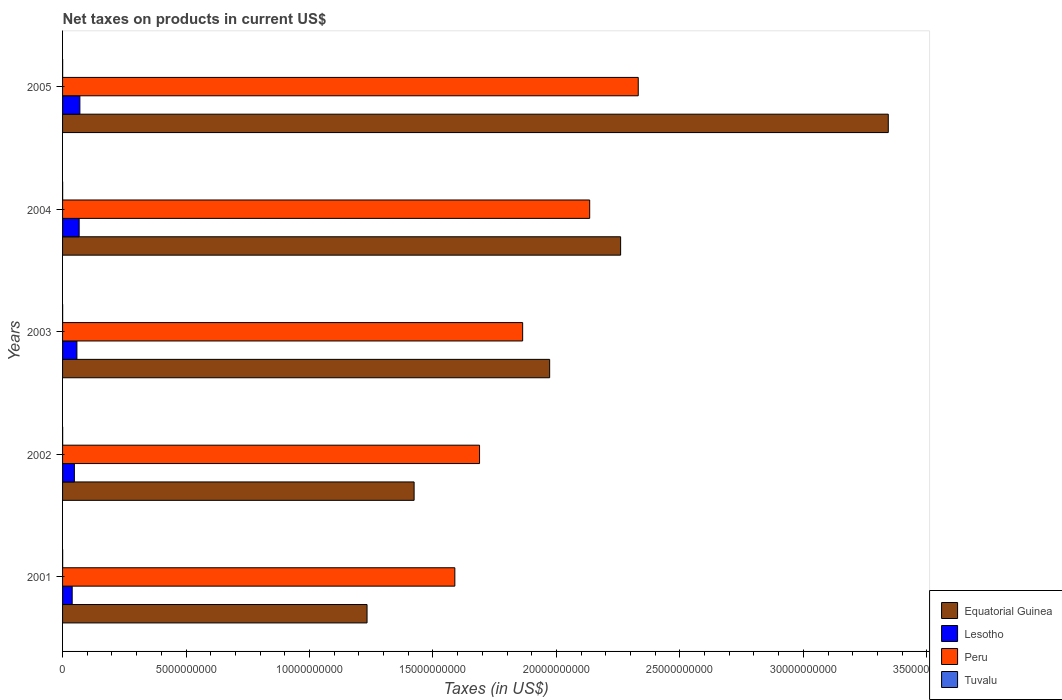How many different coloured bars are there?
Provide a succinct answer. 4. How many bars are there on the 3rd tick from the bottom?
Keep it short and to the point. 4. What is the net taxes on products in Peru in 2001?
Your answer should be very brief. 1.59e+1. Across all years, what is the maximum net taxes on products in Tuvalu?
Provide a short and direct response. 3.51e+06. Across all years, what is the minimum net taxes on products in Equatorial Guinea?
Make the answer very short. 1.23e+1. In which year was the net taxes on products in Peru minimum?
Your answer should be compact. 2001. What is the total net taxes on products in Tuvalu in the graph?
Your response must be concise. 1.58e+07. What is the difference between the net taxes on products in Lesotho in 2001 and that in 2004?
Your answer should be very brief. -2.82e+08. What is the difference between the net taxes on products in Tuvalu in 2004 and the net taxes on products in Lesotho in 2001?
Your response must be concise. -3.87e+08. What is the average net taxes on products in Tuvalu per year?
Provide a succinct answer. 3.16e+06. In the year 2005, what is the difference between the net taxes on products in Equatorial Guinea and net taxes on products in Tuvalu?
Your response must be concise. 3.34e+1. In how many years, is the net taxes on products in Tuvalu greater than 28000000000 US$?
Keep it short and to the point. 0. What is the ratio of the net taxes on products in Peru in 2002 to that in 2004?
Keep it short and to the point. 0.79. Is the difference between the net taxes on products in Equatorial Guinea in 2001 and 2003 greater than the difference between the net taxes on products in Tuvalu in 2001 and 2003?
Your answer should be compact. No. What is the difference between the highest and the second highest net taxes on products in Lesotho?
Your answer should be compact. 2.91e+07. What is the difference between the highest and the lowest net taxes on products in Peru?
Provide a succinct answer. 7.43e+09. In how many years, is the net taxes on products in Equatorial Guinea greater than the average net taxes on products in Equatorial Guinea taken over all years?
Make the answer very short. 2. Is the sum of the net taxes on products in Lesotho in 2003 and 2004 greater than the maximum net taxes on products in Peru across all years?
Offer a terse response. No. What does the 3rd bar from the top in 2005 represents?
Offer a very short reply. Lesotho. What does the 2nd bar from the bottom in 2001 represents?
Give a very brief answer. Lesotho. How many bars are there?
Provide a short and direct response. 20. Are all the bars in the graph horizontal?
Provide a succinct answer. Yes. Are the values on the major ticks of X-axis written in scientific E-notation?
Provide a succinct answer. No. Does the graph contain grids?
Provide a succinct answer. No. How are the legend labels stacked?
Provide a succinct answer. Vertical. What is the title of the graph?
Provide a succinct answer. Net taxes on products in current US$. Does "Botswana" appear as one of the legend labels in the graph?
Offer a very short reply. No. What is the label or title of the X-axis?
Your response must be concise. Taxes (in US$). What is the label or title of the Y-axis?
Offer a very short reply. Years. What is the Taxes (in US$) of Equatorial Guinea in 2001?
Offer a very short reply. 1.23e+1. What is the Taxes (in US$) of Lesotho in 2001?
Make the answer very short. 3.90e+08. What is the Taxes (in US$) in Peru in 2001?
Make the answer very short. 1.59e+1. What is the Taxes (in US$) of Tuvalu in 2001?
Your answer should be very brief. 3.51e+06. What is the Taxes (in US$) of Equatorial Guinea in 2002?
Your answer should be very brief. 1.42e+1. What is the Taxes (in US$) of Lesotho in 2002?
Provide a short and direct response. 4.78e+08. What is the Taxes (in US$) in Peru in 2002?
Your answer should be very brief. 1.69e+1. What is the Taxes (in US$) of Tuvalu in 2002?
Provide a succinct answer. 3.43e+06. What is the Taxes (in US$) in Equatorial Guinea in 2003?
Make the answer very short. 1.97e+1. What is the Taxes (in US$) in Lesotho in 2003?
Provide a short and direct response. 5.81e+08. What is the Taxes (in US$) in Peru in 2003?
Ensure brevity in your answer.  1.86e+1. What is the Taxes (in US$) in Tuvalu in 2003?
Give a very brief answer. 3.22e+06. What is the Taxes (in US$) in Equatorial Guinea in 2004?
Ensure brevity in your answer.  2.26e+1. What is the Taxes (in US$) in Lesotho in 2004?
Your answer should be compact. 6.72e+08. What is the Taxes (in US$) in Peru in 2004?
Your answer should be compact. 2.13e+1. What is the Taxes (in US$) in Tuvalu in 2004?
Offer a terse response. 2.87e+06. What is the Taxes (in US$) of Equatorial Guinea in 2005?
Keep it short and to the point. 3.34e+1. What is the Taxes (in US$) of Lesotho in 2005?
Offer a very short reply. 7.01e+08. What is the Taxes (in US$) of Peru in 2005?
Give a very brief answer. 2.33e+1. What is the Taxes (in US$) of Tuvalu in 2005?
Offer a terse response. 2.79e+06. Across all years, what is the maximum Taxes (in US$) in Equatorial Guinea?
Provide a short and direct response. 3.34e+1. Across all years, what is the maximum Taxes (in US$) in Lesotho?
Make the answer very short. 7.01e+08. Across all years, what is the maximum Taxes (in US$) in Peru?
Provide a short and direct response. 2.33e+1. Across all years, what is the maximum Taxes (in US$) in Tuvalu?
Offer a terse response. 3.51e+06. Across all years, what is the minimum Taxes (in US$) of Equatorial Guinea?
Ensure brevity in your answer.  1.23e+1. Across all years, what is the minimum Taxes (in US$) of Lesotho?
Provide a short and direct response. 3.90e+08. Across all years, what is the minimum Taxes (in US$) of Peru?
Ensure brevity in your answer.  1.59e+1. Across all years, what is the minimum Taxes (in US$) of Tuvalu?
Offer a very short reply. 2.79e+06. What is the total Taxes (in US$) of Equatorial Guinea in the graph?
Offer a very short reply. 1.02e+11. What is the total Taxes (in US$) of Lesotho in the graph?
Provide a short and direct response. 2.82e+09. What is the total Taxes (in US$) of Peru in the graph?
Provide a short and direct response. 9.61e+1. What is the total Taxes (in US$) in Tuvalu in the graph?
Give a very brief answer. 1.58e+07. What is the difference between the Taxes (in US$) of Equatorial Guinea in 2001 and that in 2002?
Offer a very short reply. -1.91e+09. What is the difference between the Taxes (in US$) of Lesotho in 2001 and that in 2002?
Give a very brief answer. -8.83e+07. What is the difference between the Taxes (in US$) of Peru in 2001 and that in 2002?
Your answer should be very brief. -1.00e+09. What is the difference between the Taxes (in US$) in Tuvalu in 2001 and that in 2002?
Your response must be concise. 8.68e+04. What is the difference between the Taxes (in US$) in Equatorial Guinea in 2001 and that in 2003?
Your answer should be very brief. -7.40e+09. What is the difference between the Taxes (in US$) of Lesotho in 2001 and that in 2003?
Your answer should be very brief. -1.91e+08. What is the difference between the Taxes (in US$) of Peru in 2001 and that in 2003?
Keep it short and to the point. -2.75e+09. What is the difference between the Taxes (in US$) of Tuvalu in 2001 and that in 2003?
Your answer should be very brief. 2.88e+05. What is the difference between the Taxes (in US$) of Equatorial Guinea in 2001 and that in 2004?
Your answer should be compact. -1.03e+1. What is the difference between the Taxes (in US$) in Lesotho in 2001 and that in 2004?
Provide a succinct answer. -2.82e+08. What is the difference between the Taxes (in US$) of Peru in 2001 and that in 2004?
Offer a terse response. -5.46e+09. What is the difference between the Taxes (in US$) in Tuvalu in 2001 and that in 2004?
Ensure brevity in your answer.  6.37e+05. What is the difference between the Taxes (in US$) of Equatorial Guinea in 2001 and that in 2005?
Your response must be concise. -2.11e+1. What is the difference between the Taxes (in US$) in Lesotho in 2001 and that in 2005?
Ensure brevity in your answer.  -3.11e+08. What is the difference between the Taxes (in US$) of Peru in 2001 and that in 2005?
Your response must be concise. -7.43e+09. What is the difference between the Taxes (in US$) of Tuvalu in 2001 and that in 2005?
Ensure brevity in your answer.  7.24e+05. What is the difference between the Taxes (in US$) of Equatorial Guinea in 2002 and that in 2003?
Make the answer very short. -5.49e+09. What is the difference between the Taxes (in US$) of Lesotho in 2002 and that in 2003?
Your answer should be compact. -1.03e+08. What is the difference between the Taxes (in US$) in Peru in 2002 and that in 2003?
Provide a succinct answer. -1.75e+09. What is the difference between the Taxes (in US$) in Tuvalu in 2002 and that in 2003?
Offer a very short reply. 2.01e+05. What is the difference between the Taxes (in US$) of Equatorial Guinea in 2002 and that in 2004?
Offer a very short reply. -8.36e+09. What is the difference between the Taxes (in US$) in Lesotho in 2002 and that in 2004?
Your answer should be very brief. -1.94e+08. What is the difference between the Taxes (in US$) in Peru in 2002 and that in 2004?
Your response must be concise. -4.46e+09. What is the difference between the Taxes (in US$) of Tuvalu in 2002 and that in 2004?
Provide a short and direct response. 5.50e+05. What is the difference between the Taxes (in US$) of Equatorial Guinea in 2002 and that in 2005?
Your answer should be very brief. -1.92e+1. What is the difference between the Taxes (in US$) of Lesotho in 2002 and that in 2005?
Ensure brevity in your answer.  -2.23e+08. What is the difference between the Taxes (in US$) in Peru in 2002 and that in 2005?
Give a very brief answer. -6.43e+09. What is the difference between the Taxes (in US$) in Tuvalu in 2002 and that in 2005?
Offer a terse response. 6.37e+05. What is the difference between the Taxes (in US$) of Equatorial Guinea in 2003 and that in 2004?
Your response must be concise. -2.87e+09. What is the difference between the Taxes (in US$) of Lesotho in 2003 and that in 2004?
Your answer should be compact. -9.11e+07. What is the difference between the Taxes (in US$) in Peru in 2003 and that in 2004?
Provide a short and direct response. -2.71e+09. What is the difference between the Taxes (in US$) of Tuvalu in 2003 and that in 2004?
Keep it short and to the point. 3.50e+05. What is the difference between the Taxes (in US$) of Equatorial Guinea in 2003 and that in 2005?
Your response must be concise. -1.37e+1. What is the difference between the Taxes (in US$) in Lesotho in 2003 and that in 2005?
Keep it short and to the point. -1.20e+08. What is the difference between the Taxes (in US$) of Peru in 2003 and that in 2005?
Your answer should be very brief. -4.68e+09. What is the difference between the Taxes (in US$) in Tuvalu in 2003 and that in 2005?
Give a very brief answer. 4.37e+05. What is the difference between the Taxes (in US$) of Equatorial Guinea in 2004 and that in 2005?
Offer a very short reply. -1.08e+1. What is the difference between the Taxes (in US$) in Lesotho in 2004 and that in 2005?
Offer a terse response. -2.91e+07. What is the difference between the Taxes (in US$) of Peru in 2004 and that in 2005?
Provide a succinct answer. -1.97e+09. What is the difference between the Taxes (in US$) in Tuvalu in 2004 and that in 2005?
Keep it short and to the point. 8.70e+04. What is the difference between the Taxes (in US$) in Equatorial Guinea in 2001 and the Taxes (in US$) in Lesotho in 2002?
Your answer should be very brief. 1.19e+1. What is the difference between the Taxes (in US$) of Equatorial Guinea in 2001 and the Taxes (in US$) of Peru in 2002?
Provide a succinct answer. -4.56e+09. What is the difference between the Taxes (in US$) in Equatorial Guinea in 2001 and the Taxes (in US$) in Tuvalu in 2002?
Your answer should be compact. 1.23e+1. What is the difference between the Taxes (in US$) of Lesotho in 2001 and the Taxes (in US$) of Peru in 2002?
Offer a very short reply. -1.65e+1. What is the difference between the Taxes (in US$) of Lesotho in 2001 and the Taxes (in US$) of Tuvalu in 2002?
Provide a succinct answer. 3.86e+08. What is the difference between the Taxes (in US$) of Peru in 2001 and the Taxes (in US$) of Tuvalu in 2002?
Offer a very short reply. 1.59e+1. What is the difference between the Taxes (in US$) of Equatorial Guinea in 2001 and the Taxes (in US$) of Lesotho in 2003?
Give a very brief answer. 1.18e+1. What is the difference between the Taxes (in US$) of Equatorial Guinea in 2001 and the Taxes (in US$) of Peru in 2003?
Your answer should be very brief. -6.30e+09. What is the difference between the Taxes (in US$) of Equatorial Guinea in 2001 and the Taxes (in US$) of Tuvalu in 2003?
Your answer should be very brief. 1.23e+1. What is the difference between the Taxes (in US$) in Lesotho in 2001 and the Taxes (in US$) in Peru in 2003?
Your response must be concise. -1.82e+1. What is the difference between the Taxes (in US$) in Lesotho in 2001 and the Taxes (in US$) in Tuvalu in 2003?
Your answer should be compact. 3.87e+08. What is the difference between the Taxes (in US$) in Peru in 2001 and the Taxes (in US$) in Tuvalu in 2003?
Make the answer very short. 1.59e+1. What is the difference between the Taxes (in US$) of Equatorial Guinea in 2001 and the Taxes (in US$) of Lesotho in 2004?
Your answer should be very brief. 1.17e+1. What is the difference between the Taxes (in US$) of Equatorial Guinea in 2001 and the Taxes (in US$) of Peru in 2004?
Offer a very short reply. -9.02e+09. What is the difference between the Taxes (in US$) of Equatorial Guinea in 2001 and the Taxes (in US$) of Tuvalu in 2004?
Your answer should be compact. 1.23e+1. What is the difference between the Taxes (in US$) in Lesotho in 2001 and the Taxes (in US$) in Peru in 2004?
Provide a succinct answer. -2.10e+1. What is the difference between the Taxes (in US$) in Lesotho in 2001 and the Taxes (in US$) in Tuvalu in 2004?
Your response must be concise. 3.87e+08. What is the difference between the Taxes (in US$) of Peru in 2001 and the Taxes (in US$) of Tuvalu in 2004?
Your answer should be compact. 1.59e+1. What is the difference between the Taxes (in US$) of Equatorial Guinea in 2001 and the Taxes (in US$) of Lesotho in 2005?
Offer a very short reply. 1.16e+1. What is the difference between the Taxes (in US$) of Equatorial Guinea in 2001 and the Taxes (in US$) of Peru in 2005?
Give a very brief answer. -1.10e+1. What is the difference between the Taxes (in US$) in Equatorial Guinea in 2001 and the Taxes (in US$) in Tuvalu in 2005?
Your answer should be very brief. 1.23e+1. What is the difference between the Taxes (in US$) in Lesotho in 2001 and the Taxes (in US$) in Peru in 2005?
Provide a short and direct response. -2.29e+1. What is the difference between the Taxes (in US$) in Lesotho in 2001 and the Taxes (in US$) in Tuvalu in 2005?
Provide a succinct answer. 3.87e+08. What is the difference between the Taxes (in US$) of Peru in 2001 and the Taxes (in US$) of Tuvalu in 2005?
Your answer should be very brief. 1.59e+1. What is the difference between the Taxes (in US$) in Equatorial Guinea in 2002 and the Taxes (in US$) in Lesotho in 2003?
Your answer should be compact. 1.37e+1. What is the difference between the Taxes (in US$) of Equatorial Guinea in 2002 and the Taxes (in US$) of Peru in 2003?
Give a very brief answer. -4.40e+09. What is the difference between the Taxes (in US$) in Equatorial Guinea in 2002 and the Taxes (in US$) in Tuvalu in 2003?
Your response must be concise. 1.42e+1. What is the difference between the Taxes (in US$) of Lesotho in 2002 and the Taxes (in US$) of Peru in 2003?
Give a very brief answer. -1.82e+1. What is the difference between the Taxes (in US$) of Lesotho in 2002 and the Taxes (in US$) of Tuvalu in 2003?
Make the answer very short. 4.75e+08. What is the difference between the Taxes (in US$) of Peru in 2002 and the Taxes (in US$) of Tuvalu in 2003?
Your answer should be compact. 1.69e+1. What is the difference between the Taxes (in US$) of Equatorial Guinea in 2002 and the Taxes (in US$) of Lesotho in 2004?
Offer a terse response. 1.36e+1. What is the difference between the Taxes (in US$) in Equatorial Guinea in 2002 and the Taxes (in US$) in Peru in 2004?
Keep it short and to the point. -7.11e+09. What is the difference between the Taxes (in US$) of Equatorial Guinea in 2002 and the Taxes (in US$) of Tuvalu in 2004?
Your answer should be very brief. 1.42e+1. What is the difference between the Taxes (in US$) of Lesotho in 2002 and the Taxes (in US$) of Peru in 2004?
Your answer should be very brief. -2.09e+1. What is the difference between the Taxes (in US$) in Lesotho in 2002 and the Taxes (in US$) in Tuvalu in 2004?
Provide a short and direct response. 4.75e+08. What is the difference between the Taxes (in US$) of Peru in 2002 and the Taxes (in US$) of Tuvalu in 2004?
Offer a terse response. 1.69e+1. What is the difference between the Taxes (in US$) of Equatorial Guinea in 2002 and the Taxes (in US$) of Lesotho in 2005?
Provide a succinct answer. 1.35e+1. What is the difference between the Taxes (in US$) in Equatorial Guinea in 2002 and the Taxes (in US$) in Peru in 2005?
Offer a very short reply. -9.08e+09. What is the difference between the Taxes (in US$) of Equatorial Guinea in 2002 and the Taxes (in US$) of Tuvalu in 2005?
Keep it short and to the point. 1.42e+1. What is the difference between the Taxes (in US$) of Lesotho in 2002 and the Taxes (in US$) of Peru in 2005?
Ensure brevity in your answer.  -2.28e+1. What is the difference between the Taxes (in US$) of Lesotho in 2002 and the Taxes (in US$) of Tuvalu in 2005?
Your answer should be compact. 4.75e+08. What is the difference between the Taxes (in US$) in Peru in 2002 and the Taxes (in US$) in Tuvalu in 2005?
Provide a succinct answer. 1.69e+1. What is the difference between the Taxes (in US$) in Equatorial Guinea in 2003 and the Taxes (in US$) in Lesotho in 2004?
Ensure brevity in your answer.  1.91e+1. What is the difference between the Taxes (in US$) of Equatorial Guinea in 2003 and the Taxes (in US$) of Peru in 2004?
Ensure brevity in your answer.  -1.62e+09. What is the difference between the Taxes (in US$) of Equatorial Guinea in 2003 and the Taxes (in US$) of Tuvalu in 2004?
Keep it short and to the point. 1.97e+1. What is the difference between the Taxes (in US$) of Lesotho in 2003 and the Taxes (in US$) of Peru in 2004?
Provide a short and direct response. -2.08e+1. What is the difference between the Taxes (in US$) in Lesotho in 2003 and the Taxes (in US$) in Tuvalu in 2004?
Provide a succinct answer. 5.78e+08. What is the difference between the Taxes (in US$) in Peru in 2003 and the Taxes (in US$) in Tuvalu in 2004?
Provide a succinct answer. 1.86e+1. What is the difference between the Taxes (in US$) in Equatorial Guinea in 2003 and the Taxes (in US$) in Lesotho in 2005?
Your answer should be compact. 1.90e+1. What is the difference between the Taxes (in US$) in Equatorial Guinea in 2003 and the Taxes (in US$) in Peru in 2005?
Keep it short and to the point. -3.59e+09. What is the difference between the Taxes (in US$) of Equatorial Guinea in 2003 and the Taxes (in US$) of Tuvalu in 2005?
Provide a succinct answer. 1.97e+1. What is the difference between the Taxes (in US$) of Lesotho in 2003 and the Taxes (in US$) of Peru in 2005?
Provide a short and direct response. -2.27e+1. What is the difference between the Taxes (in US$) in Lesotho in 2003 and the Taxes (in US$) in Tuvalu in 2005?
Offer a terse response. 5.78e+08. What is the difference between the Taxes (in US$) of Peru in 2003 and the Taxes (in US$) of Tuvalu in 2005?
Provide a succinct answer. 1.86e+1. What is the difference between the Taxes (in US$) of Equatorial Guinea in 2004 and the Taxes (in US$) of Lesotho in 2005?
Your answer should be compact. 2.19e+1. What is the difference between the Taxes (in US$) in Equatorial Guinea in 2004 and the Taxes (in US$) in Peru in 2005?
Ensure brevity in your answer.  -7.14e+08. What is the difference between the Taxes (in US$) in Equatorial Guinea in 2004 and the Taxes (in US$) in Tuvalu in 2005?
Offer a terse response. 2.26e+1. What is the difference between the Taxes (in US$) in Lesotho in 2004 and the Taxes (in US$) in Peru in 2005?
Offer a very short reply. -2.26e+1. What is the difference between the Taxes (in US$) in Lesotho in 2004 and the Taxes (in US$) in Tuvalu in 2005?
Provide a succinct answer. 6.69e+08. What is the difference between the Taxes (in US$) of Peru in 2004 and the Taxes (in US$) of Tuvalu in 2005?
Your answer should be compact. 2.13e+1. What is the average Taxes (in US$) of Equatorial Guinea per year?
Provide a succinct answer. 2.05e+1. What is the average Taxes (in US$) of Lesotho per year?
Your answer should be very brief. 5.64e+08. What is the average Taxes (in US$) in Peru per year?
Keep it short and to the point. 1.92e+1. What is the average Taxes (in US$) in Tuvalu per year?
Offer a very short reply. 3.16e+06. In the year 2001, what is the difference between the Taxes (in US$) of Equatorial Guinea and Taxes (in US$) of Lesotho?
Offer a terse response. 1.19e+1. In the year 2001, what is the difference between the Taxes (in US$) in Equatorial Guinea and Taxes (in US$) in Peru?
Offer a very short reply. -3.56e+09. In the year 2001, what is the difference between the Taxes (in US$) in Equatorial Guinea and Taxes (in US$) in Tuvalu?
Make the answer very short. 1.23e+1. In the year 2001, what is the difference between the Taxes (in US$) of Lesotho and Taxes (in US$) of Peru?
Your answer should be very brief. -1.55e+1. In the year 2001, what is the difference between the Taxes (in US$) of Lesotho and Taxes (in US$) of Tuvalu?
Give a very brief answer. 3.86e+08. In the year 2001, what is the difference between the Taxes (in US$) of Peru and Taxes (in US$) of Tuvalu?
Give a very brief answer. 1.59e+1. In the year 2002, what is the difference between the Taxes (in US$) of Equatorial Guinea and Taxes (in US$) of Lesotho?
Offer a terse response. 1.38e+1. In the year 2002, what is the difference between the Taxes (in US$) of Equatorial Guinea and Taxes (in US$) of Peru?
Make the answer very short. -2.65e+09. In the year 2002, what is the difference between the Taxes (in US$) of Equatorial Guinea and Taxes (in US$) of Tuvalu?
Provide a short and direct response. 1.42e+1. In the year 2002, what is the difference between the Taxes (in US$) of Lesotho and Taxes (in US$) of Peru?
Your answer should be compact. -1.64e+1. In the year 2002, what is the difference between the Taxes (in US$) of Lesotho and Taxes (in US$) of Tuvalu?
Provide a short and direct response. 4.75e+08. In the year 2002, what is the difference between the Taxes (in US$) of Peru and Taxes (in US$) of Tuvalu?
Your answer should be very brief. 1.69e+1. In the year 2003, what is the difference between the Taxes (in US$) of Equatorial Guinea and Taxes (in US$) of Lesotho?
Keep it short and to the point. 1.91e+1. In the year 2003, what is the difference between the Taxes (in US$) in Equatorial Guinea and Taxes (in US$) in Peru?
Provide a succinct answer. 1.09e+09. In the year 2003, what is the difference between the Taxes (in US$) in Equatorial Guinea and Taxes (in US$) in Tuvalu?
Ensure brevity in your answer.  1.97e+1. In the year 2003, what is the difference between the Taxes (in US$) in Lesotho and Taxes (in US$) in Peru?
Give a very brief answer. -1.81e+1. In the year 2003, what is the difference between the Taxes (in US$) of Lesotho and Taxes (in US$) of Tuvalu?
Offer a terse response. 5.78e+08. In the year 2003, what is the difference between the Taxes (in US$) in Peru and Taxes (in US$) in Tuvalu?
Ensure brevity in your answer.  1.86e+1. In the year 2004, what is the difference between the Taxes (in US$) in Equatorial Guinea and Taxes (in US$) in Lesotho?
Your response must be concise. 2.19e+1. In the year 2004, what is the difference between the Taxes (in US$) of Equatorial Guinea and Taxes (in US$) of Peru?
Give a very brief answer. 1.25e+09. In the year 2004, what is the difference between the Taxes (in US$) in Equatorial Guinea and Taxes (in US$) in Tuvalu?
Make the answer very short. 2.26e+1. In the year 2004, what is the difference between the Taxes (in US$) in Lesotho and Taxes (in US$) in Peru?
Your response must be concise. -2.07e+1. In the year 2004, what is the difference between the Taxes (in US$) in Lesotho and Taxes (in US$) in Tuvalu?
Offer a terse response. 6.69e+08. In the year 2004, what is the difference between the Taxes (in US$) of Peru and Taxes (in US$) of Tuvalu?
Provide a short and direct response. 2.13e+1. In the year 2005, what is the difference between the Taxes (in US$) in Equatorial Guinea and Taxes (in US$) in Lesotho?
Your answer should be very brief. 3.27e+1. In the year 2005, what is the difference between the Taxes (in US$) in Equatorial Guinea and Taxes (in US$) in Peru?
Offer a very short reply. 1.01e+1. In the year 2005, what is the difference between the Taxes (in US$) of Equatorial Guinea and Taxes (in US$) of Tuvalu?
Give a very brief answer. 3.34e+1. In the year 2005, what is the difference between the Taxes (in US$) in Lesotho and Taxes (in US$) in Peru?
Your answer should be very brief. -2.26e+1. In the year 2005, what is the difference between the Taxes (in US$) of Lesotho and Taxes (in US$) of Tuvalu?
Keep it short and to the point. 6.98e+08. In the year 2005, what is the difference between the Taxes (in US$) in Peru and Taxes (in US$) in Tuvalu?
Your answer should be very brief. 2.33e+1. What is the ratio of the Taxes (in US$) of Equatorial Guinea in 2001 to that in 2002?
Your answer should be compact. 0.87. What is the ratio of the Taxes (in US$) of Lesotho in 2001 to that in 2002?
Provide a succinct answer. 0.82. What is the ratio of the Taxes (in US$) of Peru in 2001 to that in 2002?
Keep it short and to the point. 0.94. What is the ratio of the Taxes (in US$) of Tuvalu in 2001 to that in 2002?
Your answer should be very brief. 1.03. What is the ratio of the Taxes (in US$) in Equatorial Guinea in 2001 to that in 2003?
Provide a succinct answer. 0.63. What is the ratio of the Taxes (in US$) in Lesotho in 2001 to that in 2003?
Your answer should be compact. 0.67. What is the ratio of the Taxes (in US$) of Peru in 2001 to that in 2003?
Provide a short and direct response. 0.85. What is the ratio of the Taxes (in US$) of Tuvalu in 2001 to that in 2003?
Your answer should be very brief. 1.09. What is the ratio of the Taxes (in US$) of Equatorial Guinea in 2001 to that in 2004?
Offer a terse response. 0.55. What is the ratio of the Taxes (in US$) of Lesotho in 2001 to that in 2004?
Make the answer very short. 0.58. What is the ratio of the Taxes (in US$) in Peru in 2001 to that in 2004?
Provide a short and direct response. 0.74. What is the ratio of the Taxes (in US$) of Tuvalu in 2001 to that in 2004?
Provide a short and direct response. 1.22. What is the ratio of the Taxes (in US$) of Equatorial Guinea in 2001 to that in 2005?
Your response must be concise. 0.37. What is the ratio of the Taxes (in US$) in Lesotho in 2001 to that in 2005?
Offer a terse response. 0.56. What is the ratio of the Taxes (in US$) in Peru in 2001 to that in 2005?
Your answer should be very brief. 0.68. What is the ratio of the Taxes (in US$) of Tuvalu in 2001 to that in 2005?
Provide a short and direct response. 1.26. What is the ratio of the Taxes (in US$) of Equatorial Guinea in 2002 to that in 2003?
Your answer should be very brief. 0.72. What is the ratio of the Taxes (in US$) of Lesotho in 2002 to that in 2003?
Give a very brief answer. 0.82. What is the ratio of the Taxes (in US$) of Peru in 2002 to that in 2003?
Ensure brevity in your answer.  0.91. What is the ratio of the Taxes (in US$) in Tuvalu in 2002 to that in 2003?
Make the answer very short. 1.06. What is the ratio of the Taxes (in US$) of Equatorial Guinea in 2002 to that in 2004?
Your answer should be very brief. 0.63. What is the ratio of the Taxes (in US$) of Lesotho in 2002 to that in 2004?
Provide a succinct answer. 0.71. What is the ratio of the Taxes (in US$) in Peru in 2002 to that in 2004?
Ensure brevity in your answer.  0.79. What is the ratio of the Taxes (in US$) in Tuvalu in 2002 to that in 2004?
Your answer should be compact. 1.19. What is the ratio of the Taxes (in US$) in Equatorial Guinea in 2002 to that in 2005?
Offer a terse response. 0.43. What is the ratio of the Taxes (in US$) in Lesotho in 2002 to that in 2005?
Your answer should be very brief. 0.68. What is the ratio of the Taxes (in US$) in Peru in 2002 to that in 2005?
Your response must be concise. 0.72. What is the ratio of the Taxes (in US$) in Tuvalu in 2002 to that in 2005?
Offer a terse response. 1.23. What is the ratio of the Taxes (in US$) of Equatorial Guinea in 2003 to that in 2004?
Offer a terse response. 0.87. What is the ratio of the Taxes (in US$) in Lesotho in 2003 to that in 2004?
Your answer should be very brief. 0.86. What is the ratio of the Taxes (in US$) of Peru in 2003 to that in 2004?
Your response must be concise. 0.87. What is the ratio of the Taxes (in US$) of Tuvalu in 2003 to that in 2004?
Offer a very short reply. 1.12. What is the ratio of the Taxes (in US$) of Equatorial Guinea in 2003 to that in 2005?
Give a very brief answer. 0.59. What is the ratio of the Taxes (in US$) of Lesotho in 2003 to that in 2005?
Your answer should be very brief. 0.83. What is the ratio of the Taxes (in US$) in Peru in 2003 to that in 2005?
Provide a short and direct response. 0.8. What is the ratio of the Taxes (in US$) of Tuvalu in 2003 to that in 2005?
Your answer should be compact. 1.16. What is the ratio of the Taxes (in US$) in Equatorial Guinea in 2004 to that in 2005?
Make the answer very short. 0.68. What is the ratio of the Taxes (in US$) of Lesotho in 2004 to that in 2005?
Your answer should be very brief. 0.96. What is the ratio of the Taxes (in US$) of Peru in 2004 to that in 2005?
Keep it short and to the point. 0.92. What is the ratio of the Taxes (in US$) of Tuvalu in 2004 to that in 2005?
Make the answer very short. 1.03. What is the difference between the highest and the second highest Taxes (in US$) of Equatorial Guinea?
Ensure brevity in your answer.  1.08e+1. What is the difference between the highest and the second highest Taxes (in US$) in Lesotho?
Provide a succinct answer. 2.91e+07. What is the difference between the highest and the second highest Taxes (in US$) in Peru?
Provide a succinct answer. 1.97e+09. What is the difference between the highest and the second highest Taxes (in US$) of Tuvalu?
Ensure brevity in your answer.  8.68e+04. What is the difference between the highest and the lowest Taxes (in US$) of Equatorial Guinea?
Provide a short and direct response. 2.11e+1. What is the difference between the highest and the lowest Taxes (in US$) in Lesotho?
Provide a short and direct response. 3.11e+08. What is the difference between the highest and the lowest Taxes (in US$) of Peru?
Offer a terse response. 7.43e+09. What is the difference between the highest and the lowest Taxes (in US$) in Tuvalu?
Your response must be concise. 7.24e+05. 